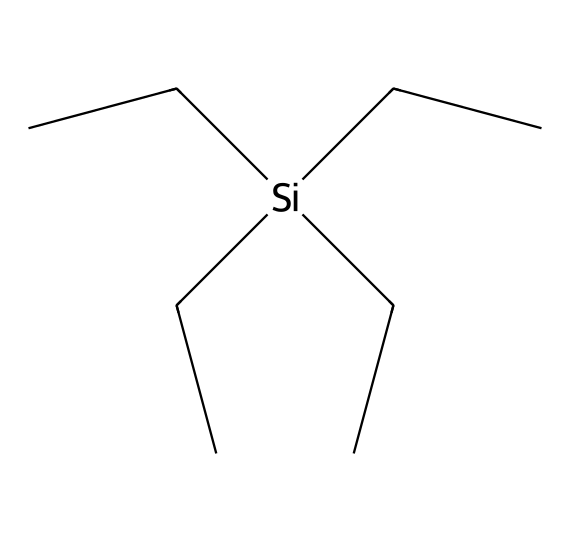What is the primary element in tetraethylsilane? The structure shows that silicon (Si) is the central atom surrounded by ethyl (C2H5) groups, indicating that silicon is the primary element.
Answer: silicon How many ethyl groups are attached to the silicon atom? Analyzing the structure reveals that there are four ethyl (C2H5) groups connected to the silicon atom, as indicated by the four branching groups in the SMILES notation.
Answer: four What is the molecular formula of tetraethylsilane? Each ethyl group contributes C2H5, and there are four of them, plus one silicon atom, leading to a total formula of Si(C2H5)4, which simplifies to C8H20Si.
Answer: C8H20Si What type of compound is tetraethylsilane? The presence of silicon bonded to organic groups (ethyl) categorizes this compound as an organosilicon compound.
Answer: organosilicon What is the total number of hydrogen atoms in tetraethylsilane? Each of the four ethyl groups contributes 5 hydrogen atoms (4 x 5 = 20), and there are no additional hydrogen atoms from the silicon, totaling 20 hydrogen atoms.
Answer: 20 Does tetraethylsilane contain any functional groups? Tetraethylsilane is composed solely of silicon and ethyl groups, with no specific functional groups present in its structure, indicating it is a saturated compound.
Answer: no How many covalent bonds does silicon form in tetraethylsilane? The silicon atom in tetraethylsilane forms four covalent bonds, one with each of the four ethyl groups, as indicated by the connections in the chemical structure.
Answer: four 